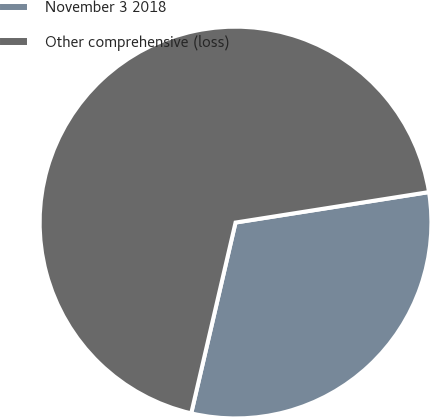Convert chart. <chart><loc_0><loc_0><loc_500><loc_500><pie_chart><fcel>November 3 2018<fcel>Other comprehensive (loss)<nl><fcel>31.12%<fcel>68.88%<nl></chart> 